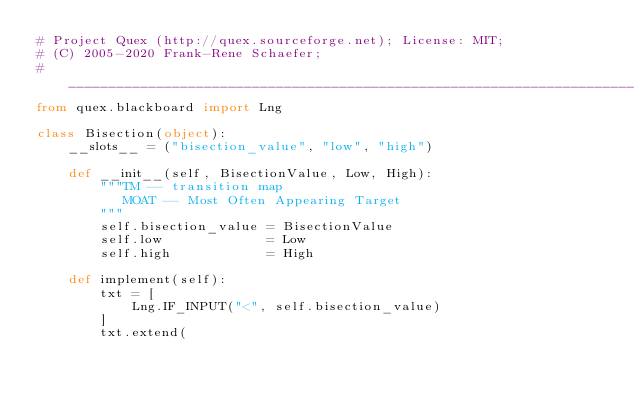<code> <loc_0><loc_0><loc_500><loc_500><_Python_># Project Quex (http://quex.sourceforge.net); License: MIT;
# (C) 2005-2020 Frank-Rene Schaefer; 
#_______________________________________________________________________________
from quex.blackboard import Lng

class Bisection(object):
    __slots__ = ("bisection_value", "low", "high")

    def __init__(self, BisectionValue, Low, High):
        """TM -- transition map
           MOAT -- Most Often Appearing Target
        """
        self.bisection_value = BisectionValue
        self.low             = Low
        self.high            = High

    def implement(self):
        txt = [
            Lng.IF_INPUT("<", self.bisection_value)
        ]
        txt.extend(</code> 